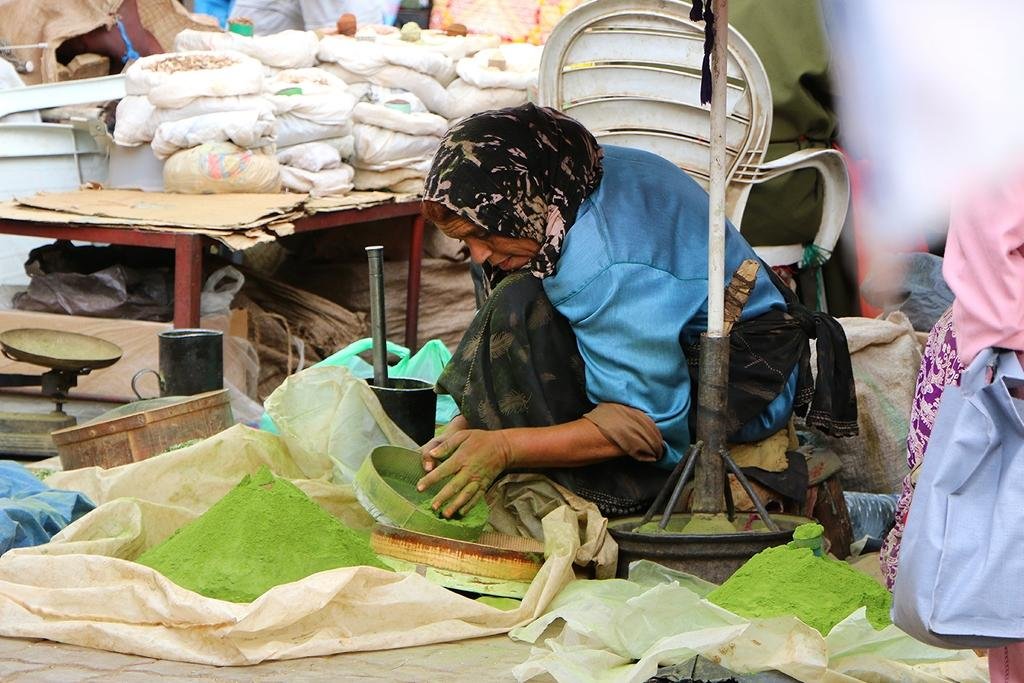Who is present in the image? There is a woman in the image. What is the woman wearing? The woman is wearing clothes. What is the woman holding in her hand? The woman is holding an object in her hand. What type of bags can be seen in the image? There are plastic bags and jute bags in the image. What type of furniture is in the image? There is a chair in the image. What other object can be seen in the image? There is a pole in the image. How does the woman offer comfort to the spark in the image? There is no spark present in the image, and the woman is not offering comfort to anything. 